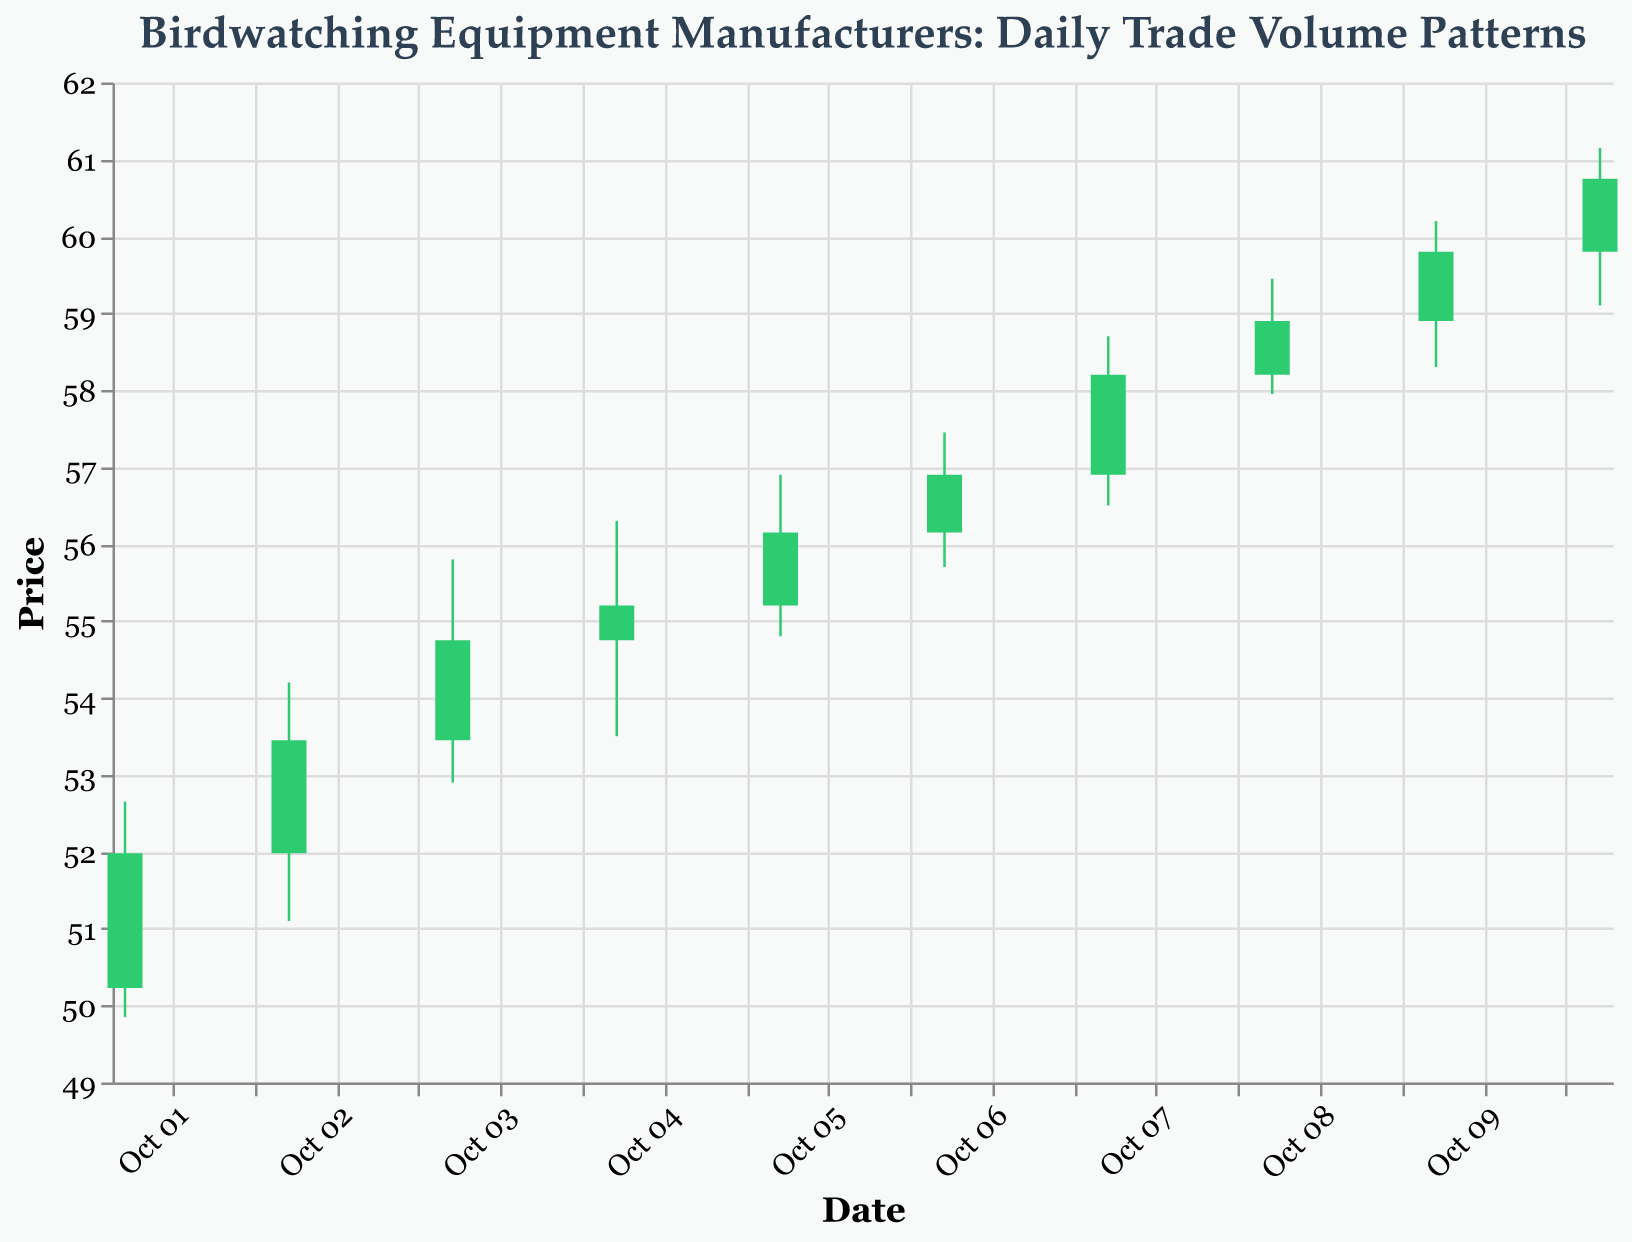How many days are represented in the plot? Count the number of unique dates listed on the x-axis.
Answer: 10 Which day had the highest daily trading volume? Find the day with the highest value on the volume axis.
Answer: 2023-10-07 What was the closing price on 2023-10-04? Locate the date 2023-10-04 on the x-axis and find the corresponding closing price.
Answer: 55.20 Which day had a higher closing price: 2023-10-02 or 2023-10-06? Compare the closing prices of 2023-10-02 and 2023-10-06.
Answer: 2023-10-06 What's the average daily trading volume over the ten days? Sum all daily trading volumes and divide by the number of days. \( \frac{(150000 + 170500 + 160200 + 180300 + 175500 + 189000 + 194500 + 160000 + 162300 + 170900)}{10} \approx 171820 \)
Answer: 171820 Which day had the largest difference between the high and low prices? Calculate the difference between high and low prices for each day and find the maximum difference. \( 2023-10-09: 60.20 - 58.30 = 1.90 \)
Answer: 2023-10-09 On which day did the stock price see the biggest rise in closing price from the previous day? Calculate the day-over-day changes in closing prices and find the maximum increase. \( 2023-10-02: 53.45 - 51.98 = 1.47 \)
Answer: 2023-10-02 Did the stock price ever fall on consecutive days? If so, when? Look for consecutive days where the closing price is lower than the previous day's closing price.
Answer: No On which day did the stock price close higher than it opened, yet had the lowest trading volume among such days? Find the days where the closing price is higher than the opening price, then find the one with the lowest volume. \( 2023-10-01, 2023-10-02, 2023-10-03, 2023-10-04, 2023-10-05, 2023-10-06, 2023-10-07, 2023-10-09, 2023-10-10 \quad \text{Range:} \)
Answer: 2023-10-01 